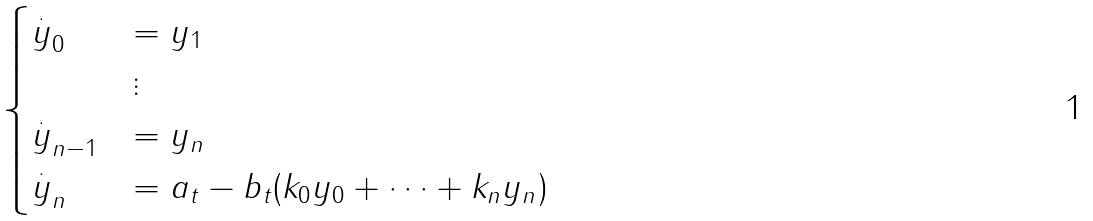Convert formula to latex. <formula><loc_0><loc_0><loc_500><loc_500>\begin{cases} \overset { . } { y } _ { 0 } & = y _ { 1 } \\ & \vdots \\ \overset { . } { y } _ { n - 1 } & = y _ { n } \\ \overset { . } { y } _ { n } & = a _ { t } - b _ { t } ( k _ { 0 } y _ { 0 } + \cdots + k _ { n } y _ { n } ) \end{cases}</formula> 